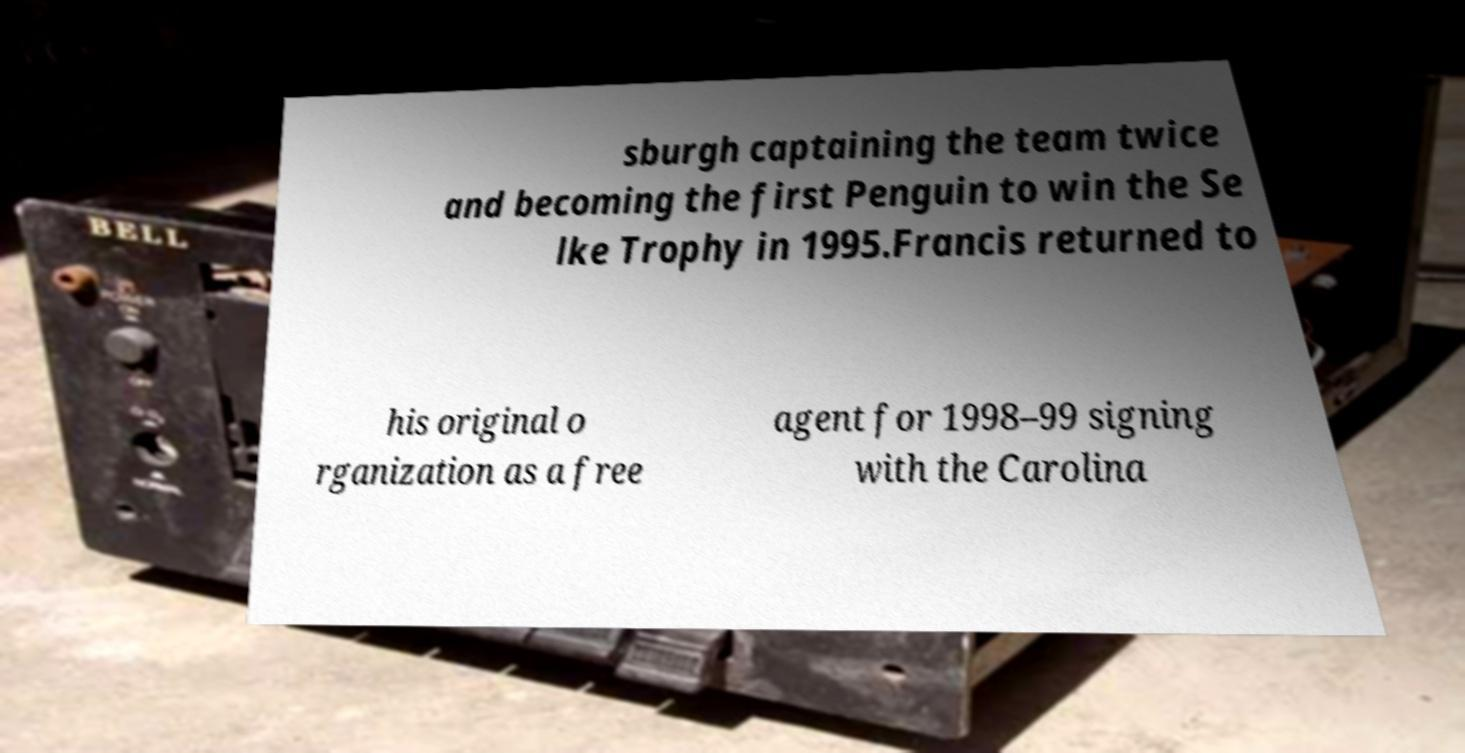For documentation purposes, I need the text within this image transcribed. Could you provide that? sburgh captaining the team twice and becoming the first Penguin to win the Se lke Trophy in 1995.Francis returned to his original o rganization as a free agent for 1998–99 signing with the Carolina 